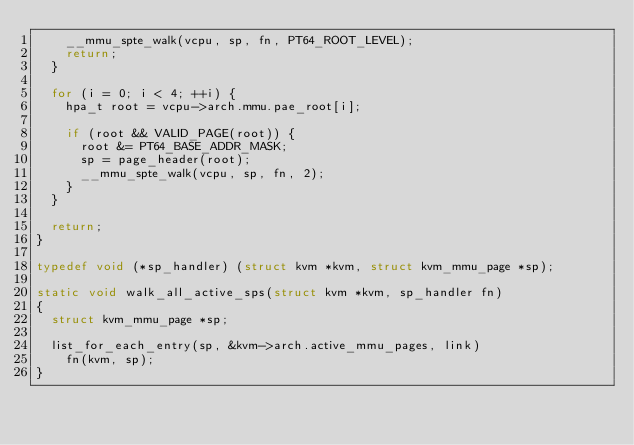Convert code to text. <code><loc_0><loc_0><loc_500><loc_500><_C_>		__mmu_spte_walk(vcpu, sp, fn, PT64_ROOT_LEVEL);
		return;
	}

	for (i = 0; i < 4; ++i) {
		hpa_t root = vcpu->arch.mmu.pae_root[i];

		if (root && VALID_PAGE(root)) {
			root &= PT64_BASE_ADDR_MASK;
			sp = page_header(root);
			__mmu_spte_walk(vcpu, sp, fn, 2);
		}
	}

	return;
}

typedef void (*sp_handler) (struct kvm *kvm, struct kvm_mmu_page *sp);

static void walk_all_active_sps(struct kvm *kvm, sp_handler fn)
{
	struct kvm_mmu_page *sp;

	list_for_each_entry(sp, &kvm->arch.active_mmu_pages, link)
		fn(kvm, sp);
}
</code> 